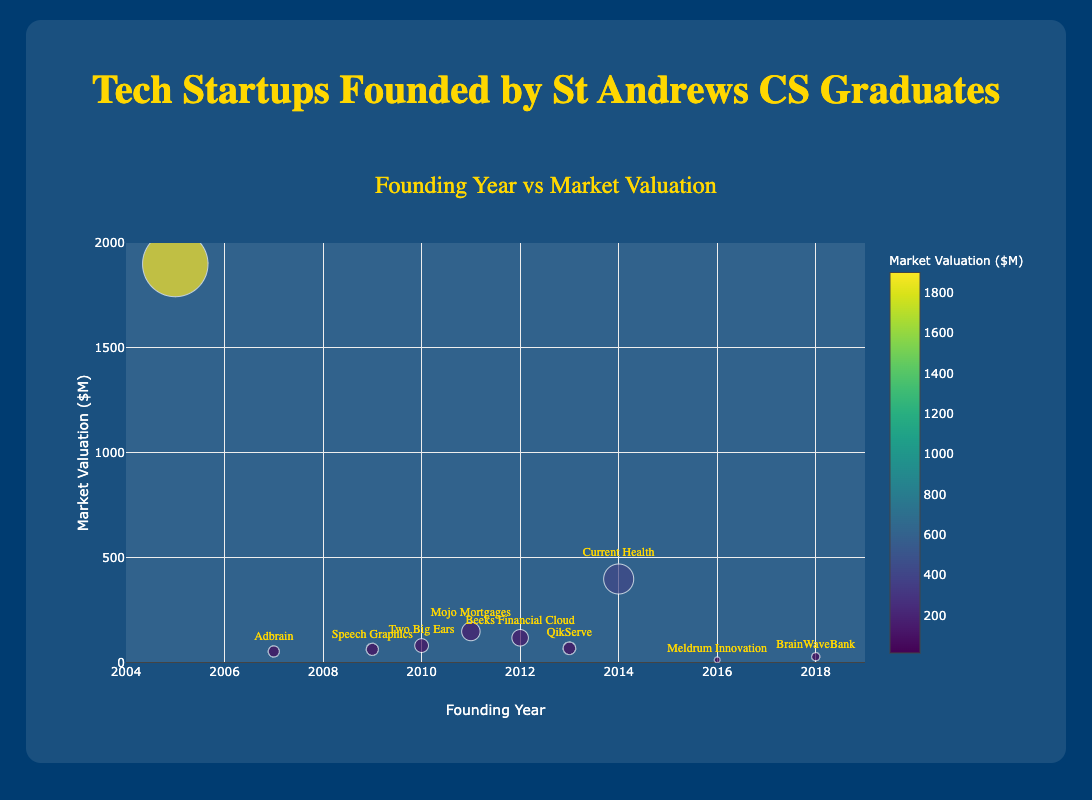What is the title of the chart? The title is displayed prominently at the top of the chart. It reads "Tech Startups Founded by St Andrews CS Graduates."
Answer: Tech Startups Founded by St Andrews CS Graduates Which company has the highest market valuation? By observing the y-axis, we can see that the point associated with the highest market valuation is Skyscanner, which is valued at $1900M.
Answer: Skyscanner How many startups were founded in or after 2010? By examining the x-axis and counting the number of points from 2010 onwards: Two Big Ears (2010), Beeks Financial Cloud (2012), QikServe (2013), Current Health (2014), Meldrum Innovation (2016), and BrainWaveBank (2018), there are 6 startups in this period.
Answer: 6 What is the average market valuation of startups founded between 2005 and 2010? Startups founded between 2005 and 2010: Skyscanner (1900), Two Big Ears (83), Adbrain (55), Speech Graphics (65). Calculate average: (1900 + 83 + 55 + 65) / 4 = 525.75.
Answer: 525.75 Compare the market valuation of QikServe and Speech Graphics. Which one is higher? By noting the market valuations, QikServe has a valuation of $70M and Speech Graphics has a valuation of $65M. Therefore, QikServe has a higher valuation.
Answer: QikServe What is the range of founding years for the startups displayed? The x-axis shows the founding years ranging from the earliest founding in 2005 to the latest in 2018.
Answer: 2005 to 2018 Which startup has the smallest market valuation and what is it? By looking at the market valuations on the y-axis, the startup with the smallest valuation is Meldrum Innovation, valued at $15M.
Answer: Meldrum Innovation, $15M What is the median market valuation of all the startups? To find the median, list the market valuations in ascending order: 15, 30, 55, 65, 70, 83, 120, 150, 400, 1900. The median is the average of the two middle numbers: (70 + 83) / 2 = 76.5.
Answer: 76.5 Which year has the highest frequency of startups founded? There is no year with more than one startup being founded; each startup was founded in a distinct year. Hence, the frequency is 1 for each year.
Answer: Each year has a frequency of 1 What color scale is used for the markers? The color scale used is Viridis, which ranges through different colors to represent varying market valuations.
Answer: Viridis 